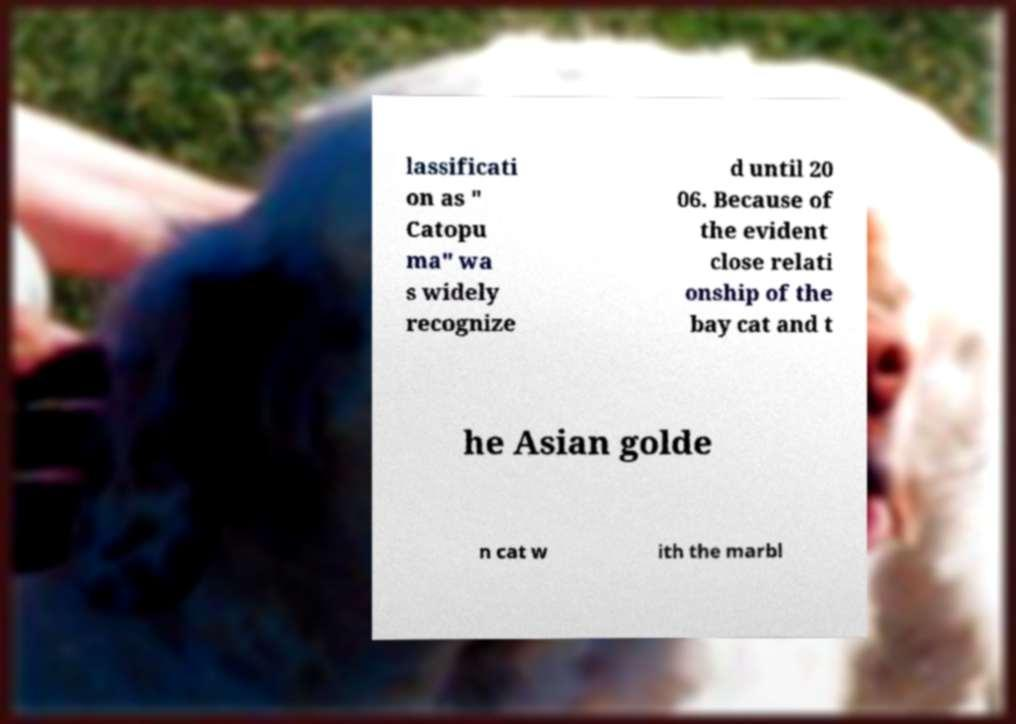I need the written content from this picture converted into text. Can you do that? lassificati on as " Catopu ma" wa s widely recognize d until 20 06. Because of the evident close relati onship of the bay cat and t he Asian golde n cat w ith the marbl 